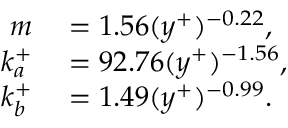Convert formula to latex. <formula><loc_0><loc_0><loc_500><loc_500>\begin{array} { r l } { m } & = 1 . 5 6 ( y ^ { + } ) ^ { - 0 . 2 2 } , } \\ { k _ { a } ^ { + } } & = 9 2 . 7 6 ( y ^ { + } ) ^ { - 1 . 5 6 } , } \\ { k _ { b } ^ { + } } & = 1 . 4 9 ( y ^ { + } ) ^ { - 0 . 9 9 } . } \end{array}</formula> 